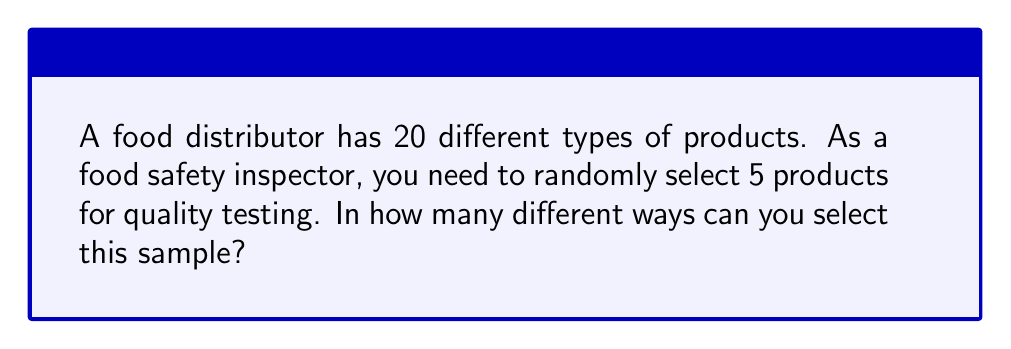Help me with this question. To solve this problem, we need to use the combination formula. Here's why:

1. The order of selection doesn't matter (selecting product A then B is the same as selecting B then A).
2. We are selecting a subset of items from a larger set without replacement.

The combination formula is:

$$ C(n,r) = \frac{n!}{r!(n-r)!} $$

Where:
- $n$ is the total number of items to choose from (20 in this case)
- $r$ is the number of items being chosen (5 in this case)

Let's plug in our values:

$$ C(20,5) = \frac{20!}{5!(20-5)!} = \frac{20!}{5!(15)!} $$

Now, let's calculate this step-by-step:

1) $\frac{20 * 19 * 18 * 17 * 16 * 15!}{(5 * 4 * 3 * 2 * 1) * 15!}$

2) The 15! cancels out in the numerator and denominator:

   $\frac{20 * 19 * 18 * 17 * 16}{5 * 4 * 3 * 2 * 1}$

3) Multiply the numerator and denominator:

   $\frac{1,860,480}{120}$

4) Divide:

   15,504

Therefore, there are 15,504 different ways to select 5 products out of 20 for quality testing.
Answer: 15,504 